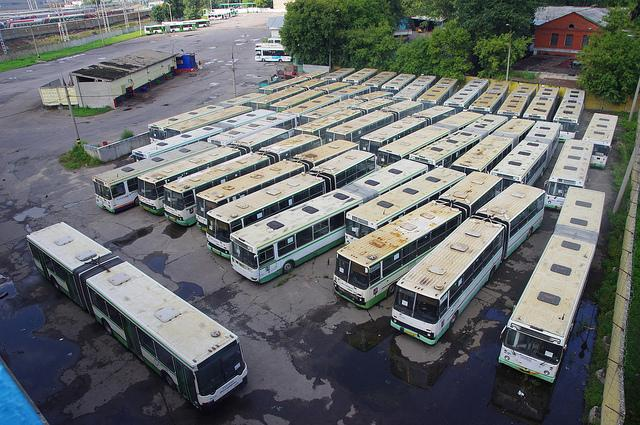What phrase best describes this place? bus depot 